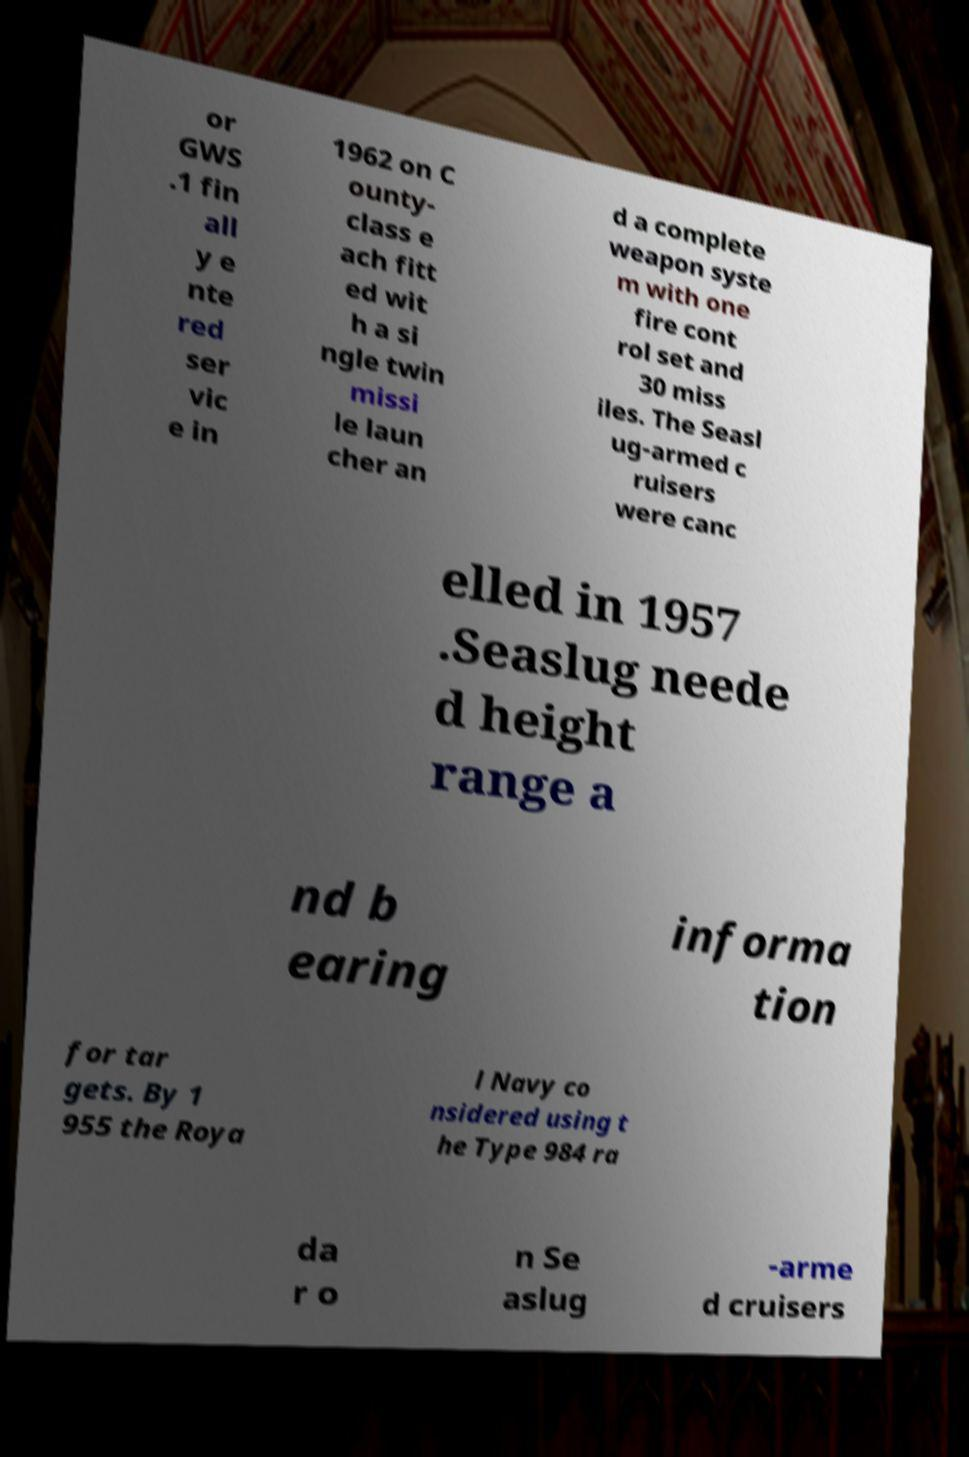Can you accurately transcribe the text from the provided image for me? or GWS .1 fin all y e nte red ser vic e in 1962 on C ounty- class e ach fitt ed wit h a si ngle twin missi le laun cher an d a complete weapon syste m with one fire cont rol set and 30 miss iles. The Seasl ug-armed c ruisers were canc elled in 1957 .Seaslug neede d height range a nd b earing informa tion for tar gets. By 1 955 the Roya l Navy co nsidered using t he Type 984 ra da r o n Se aslug -arme d cruisers 